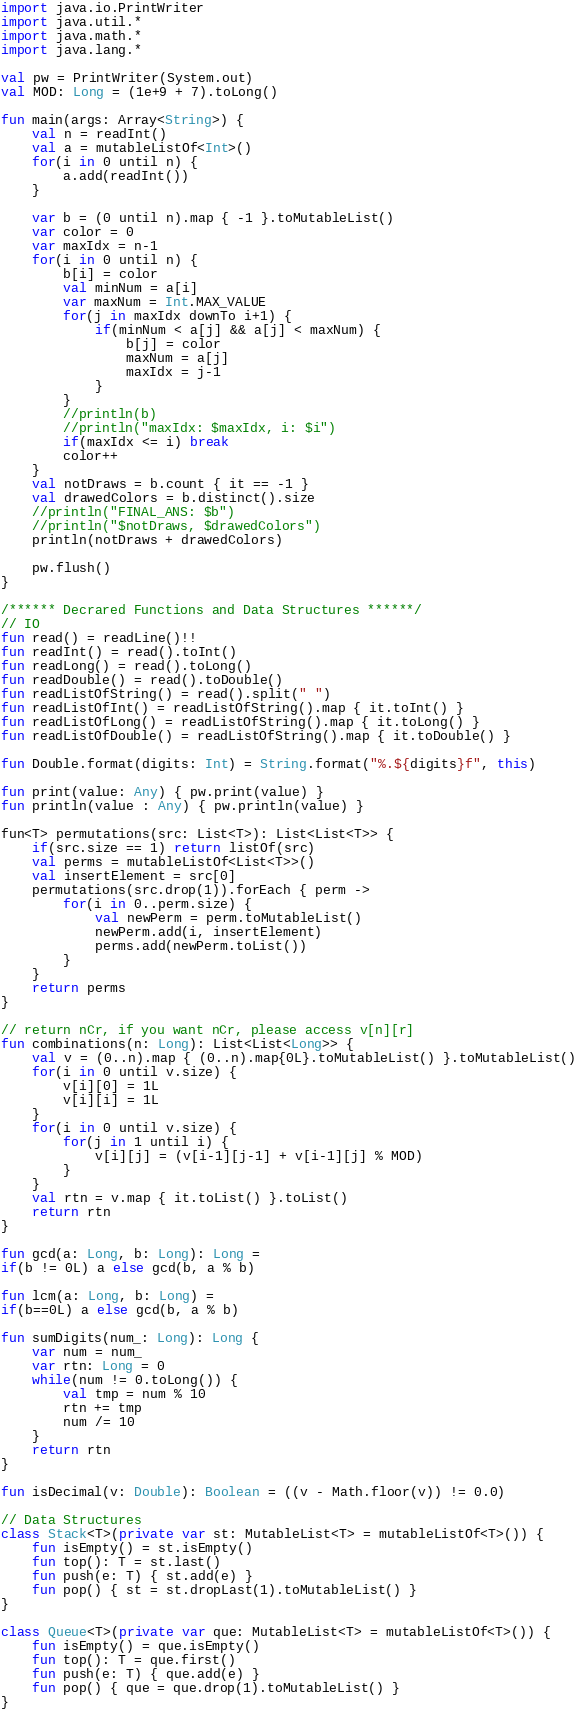<code> <loc_0><loc_0><loc_500><loc_500><_Kotlin_>import java.io.PrintWriter
import java.util.*
import java.math.*
import java.lang.*

val pw = PrintWriter(System.out)
val MOD: Long = (1e+9 + 7).toLong()

fun main(args: Array<String>) {
    val n = readInt()
    val a = mutableListOf<Int>()
    for(i in 0 until n) {
        a.add(readInt())
    }

    var b = (0 until n).map { -1 }.toMutableList()
    var color = 0
    var maxIdx = n-1
    for(i in 0 until n) {
        b[i] = color
        val minNum = a[i]
        var maxNum = Int.MAX_VALUE
        for(j in maxIdx downTo i+1) {
            if(minNum < a[j] && a[j] < maxNum) {
                b[j] = color       
                maxNum = a[j]
                maxIdx = j-1
            }
        }
        //println(b)
        //println("maxIdx: $maxIdx, i: $i")
        if(maxIdx <= i) break
        color++
    }
    val notDraws = b.count { it == -1 }
    val drawedColors = b.distinct().size
    //println("FINAL_ANS: $b")
    //println("$notDraws, $drawedColors")
    println(notDraws + drawedColors)

    pw.flush()
}

/****** Decrared Functions and Data Structures ******/
// IO
fun read() = readLine()!!
fun readInt() = read().toInt()
fun readLong() = read().toLong()
fun readDouble() = read().toDouble()
fun readListOfString() = read().split(" ")
fun readListOfInt() = readListOfString().map { it.toInt() }
fun readListOfLong() = readListOfString().map { it.toLong() }
fun readListOfDouble() = readListOfString().map { it.toDouble() }

fun Double.format(digits: Int) = String.format("%.${digits}f", this)

fun print(value: Any) { pw.print(value) }
fun println(value : Any) { pw.println(value) }

fun<T> permutations(src: List<T>): List<List<T>> {
    if(src.size == 1) return listOf(src)
    val perms = mutableListOf<List<T>>()
    val insertElement = src[0]
    permutations(src.drop(1)).forEach { perm ->
        for(i in 0..perm.size) {
            val newPerm = perm.toMutableList()
            newPerm.add(i, insertElement)
            perms.add(newPerm.toList())
        }
    }
    return perms
}

// return nCr, if you want nCr, please access v[n][r]
fun combinations(n: Long): List<List<Long>> {
    val v = (0..n).map { (0..n).map{0L}.toMutableList() }.toMutableList()
    for(i in 0 until v.size) {
        v[i][0] = 1L
        v[i][i] = 1L
    }
    for(i in 0 until v.size) {
        for(j in 1 until i) {
            v[i][j] = (v[i-1][j-1] + v[i-1][j] % MOD)
        }
    }
    val rtn = v.map { it.toList() }.toList()
    return rtn 
}

fun gcd(a: Long, b: Long): Long = 
if(b != 0L) a else gcd(b, a % b)

fun lcm(a: Long, b: Long) = 
if(b==0L) a else gcd(b, a % b)

fun sumDigits(num_: Long): Long {
    var num = num_
    var rtn: Long = 0
    while(num != 0.toLong()) {
        val tmp = num % 10
        rtn += tmp
        num /= 10
    }
    return rtn
}

fun isDecimal(v: Double): Boolean = ((v - Math.floor(v)) != 0.0)

// Data Structures
class Stack<T>(private var st: MutableList<T> = mutableListOf<T>()) {
    fun isEmpty() = st.isEmpty()
    fun top(): T = st.last()
    fun push(e: T) { st.add(e) }
    fun pop() { st = st.dropLast(1).toMutableList() }
}

class Queue<T>(private var que: MutableList<T> = mutableListOf<T>()) {
    fun isEmpty() = que.isEmpty()
    fun top(): T = que.first()
    fun push(e: T) { que.add(e) }
    fun pop() { que = que.drop(1).toMutableList() }
}
</code> 